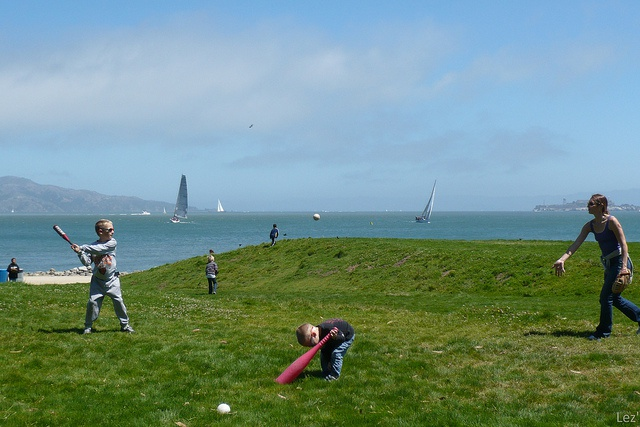Describe the objects in this image and their specific colors. I can see people in lightblue, black, gray, darkgreen, and navy tones, people in lightblue, black, gray, lightgray, and darkgray tones, people in lightblue, black, and gray tones, baseball bat in lightblue, brown, maroon, and salmon tones, and boat in lightblue, gray, blue, and darkgray tones in this image. 